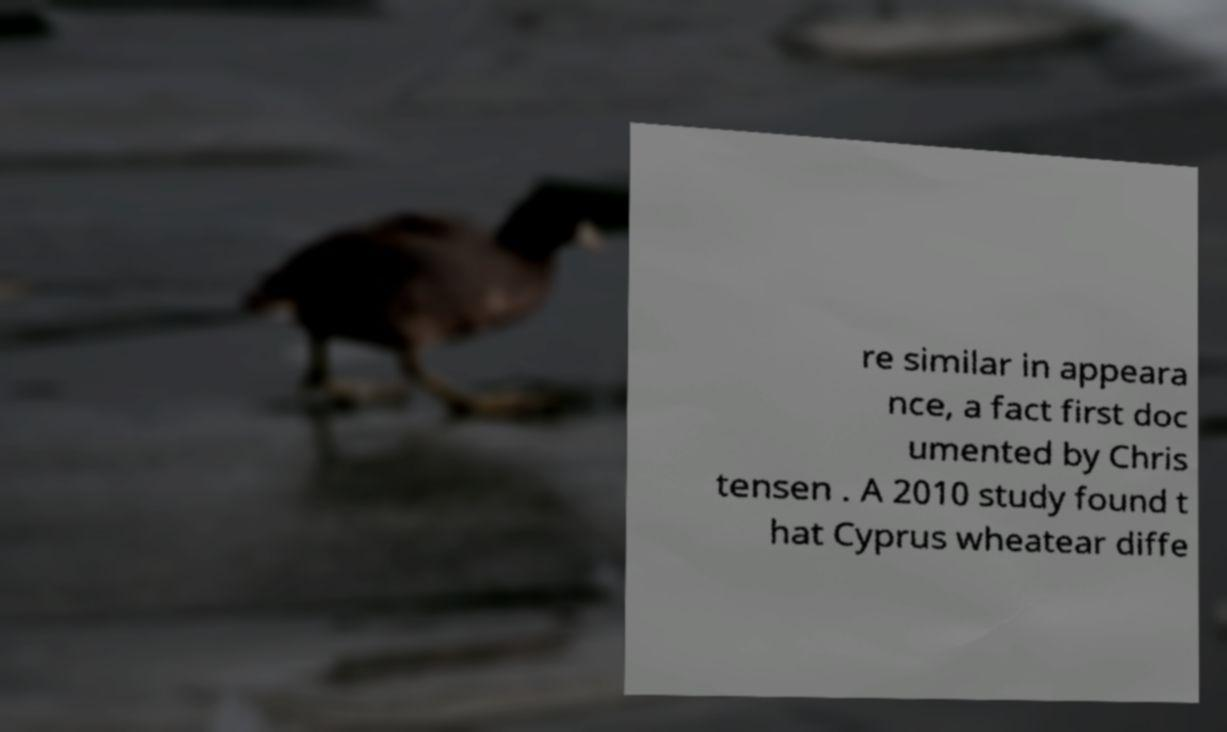Please read and relay the text visible in this image. What does it say? re similar in appeara nce, a fact first doc umented by Chris tensen . A 2010 study found t hat Cyprus wheatear diffe 